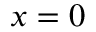Convert formula to latex. <formula><loc_0><loc_0><loc_500><loc_500>x = 0</formula> 